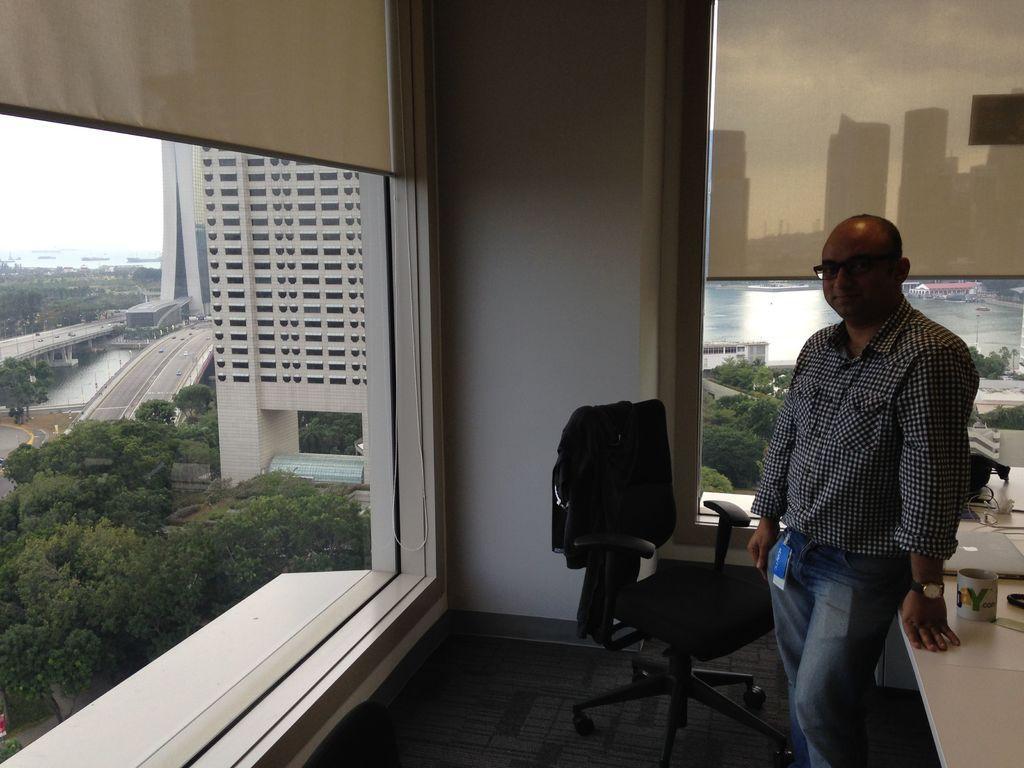Could you give a brief overview of what you see in this image? In this image I can see a person wearing shirt and jeans is standing. I can see the black colored chair, a white colored desk and in the desk I can see a cup, a laptop and few other objects. I can see two windows through which I can see few buildings, few trees, the water and the sky. 